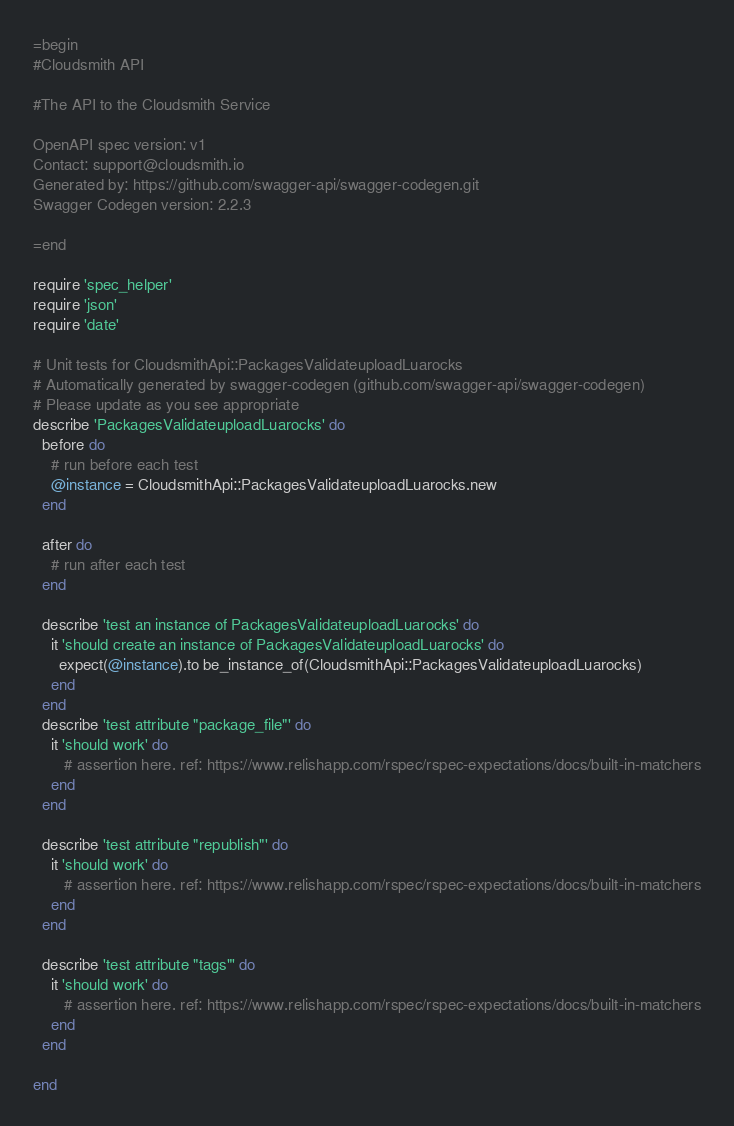Convert code to text. <code><loc_0><loc_0><loc_500><loc_500><_Ruby_>=begin
#Cloudsmith API

#The API to the Cloudsmith Service

OpenAPI spec version: v1
Contact: support@cloudsmith.io
Generated by: https://github.com/swagger-api/swagger-codegen.git
Swagger Codegen version: 2.2.3

=end

require 'spec_helper'
require 'json'
require 'date'

# Unit tests for CloudsmithApi::PackagesValidateuploadLuarocks
# Automatically generated by swagger-codegen (github.com/swagger-api/swagger-codegen)
# Please update as you see appropriate
describe 'PackagesValidateuploadLuarocks' do
  before do
    # run before each test
    @instance = CloudsmithApi::PackagesValidateuploadLuarocks.new
  end

  after do
    # run after each test
  end

  describe 'test an instance of PackagesValidateuploadLuarocks' do
    it 'should create an instance of PackagesValidateuploadLuarocks' do
      expect(@instance).to be_instance_of(CloudsmithApi::PackagesValidateuploadLuarocks)
    end
  end
  describe 'test attribute "package_file"' do
    it 'should work' do
       # assertion here. ref: https://www.relishapp.com/rspec/rspec-expectations/docs/built-in-matchers
    end
  end

  describe 'test attribute "republish"' do
    it 'should work' do
       # assertion here. ref: https://www.relishapp.com/rspec/rspec-expectations/docs/built-in-matchers
    end
  end

  describe 'test attribute "tags"' do
    it 'should work' do
       # assertion here. ref: https://www.relishapp.com/rspec/rspec-expectations/docs/built-in-matchers
    end
  end

end

</code> 